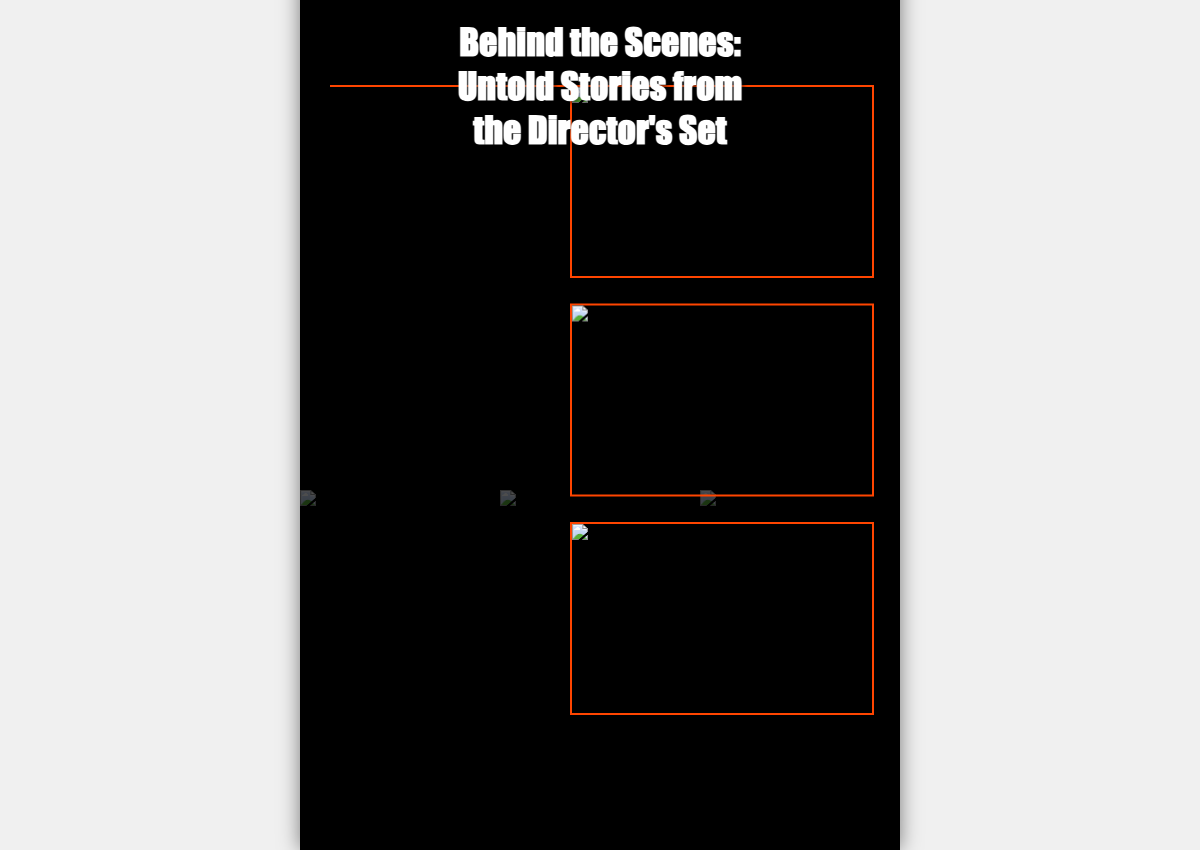What is the title of the book? The title is prominently displayed at the top of the cover in a bold font.
Answer: Behind the Scenes: Untold Stories from the Director's Set How many scripts are shown in the background collage? The collage visually contains three images of script pages.
Answer: Three Which director is associated with the photo featuring Tippi Hedren? The description beneath the photo specifies that it features Alfred Hitchcock.
Answer: Alfred Hitchcock What is the setting of the photo with Jack Nicholson? The description indicates that this photo is taken on the set of 'The Shining'.
Answer: The Shining What color is used for the accent line on the cover? The accent line is specifically mentioned to be orange in color.
Answer: Orange Which director is giving direction on the set of 'Titanic'? The description states that it features James Cameron giving direction.
Answer: James Cameron Which film is associated with the script pages in the lower-left corner? The tags with the script pages indicate they are from 'Gone with the Wind'.
Answer: Gone with the Wind What effect is applied to the candid photo's image on hover? The image is described to scale up when hovered over.
Answer: Scale up 